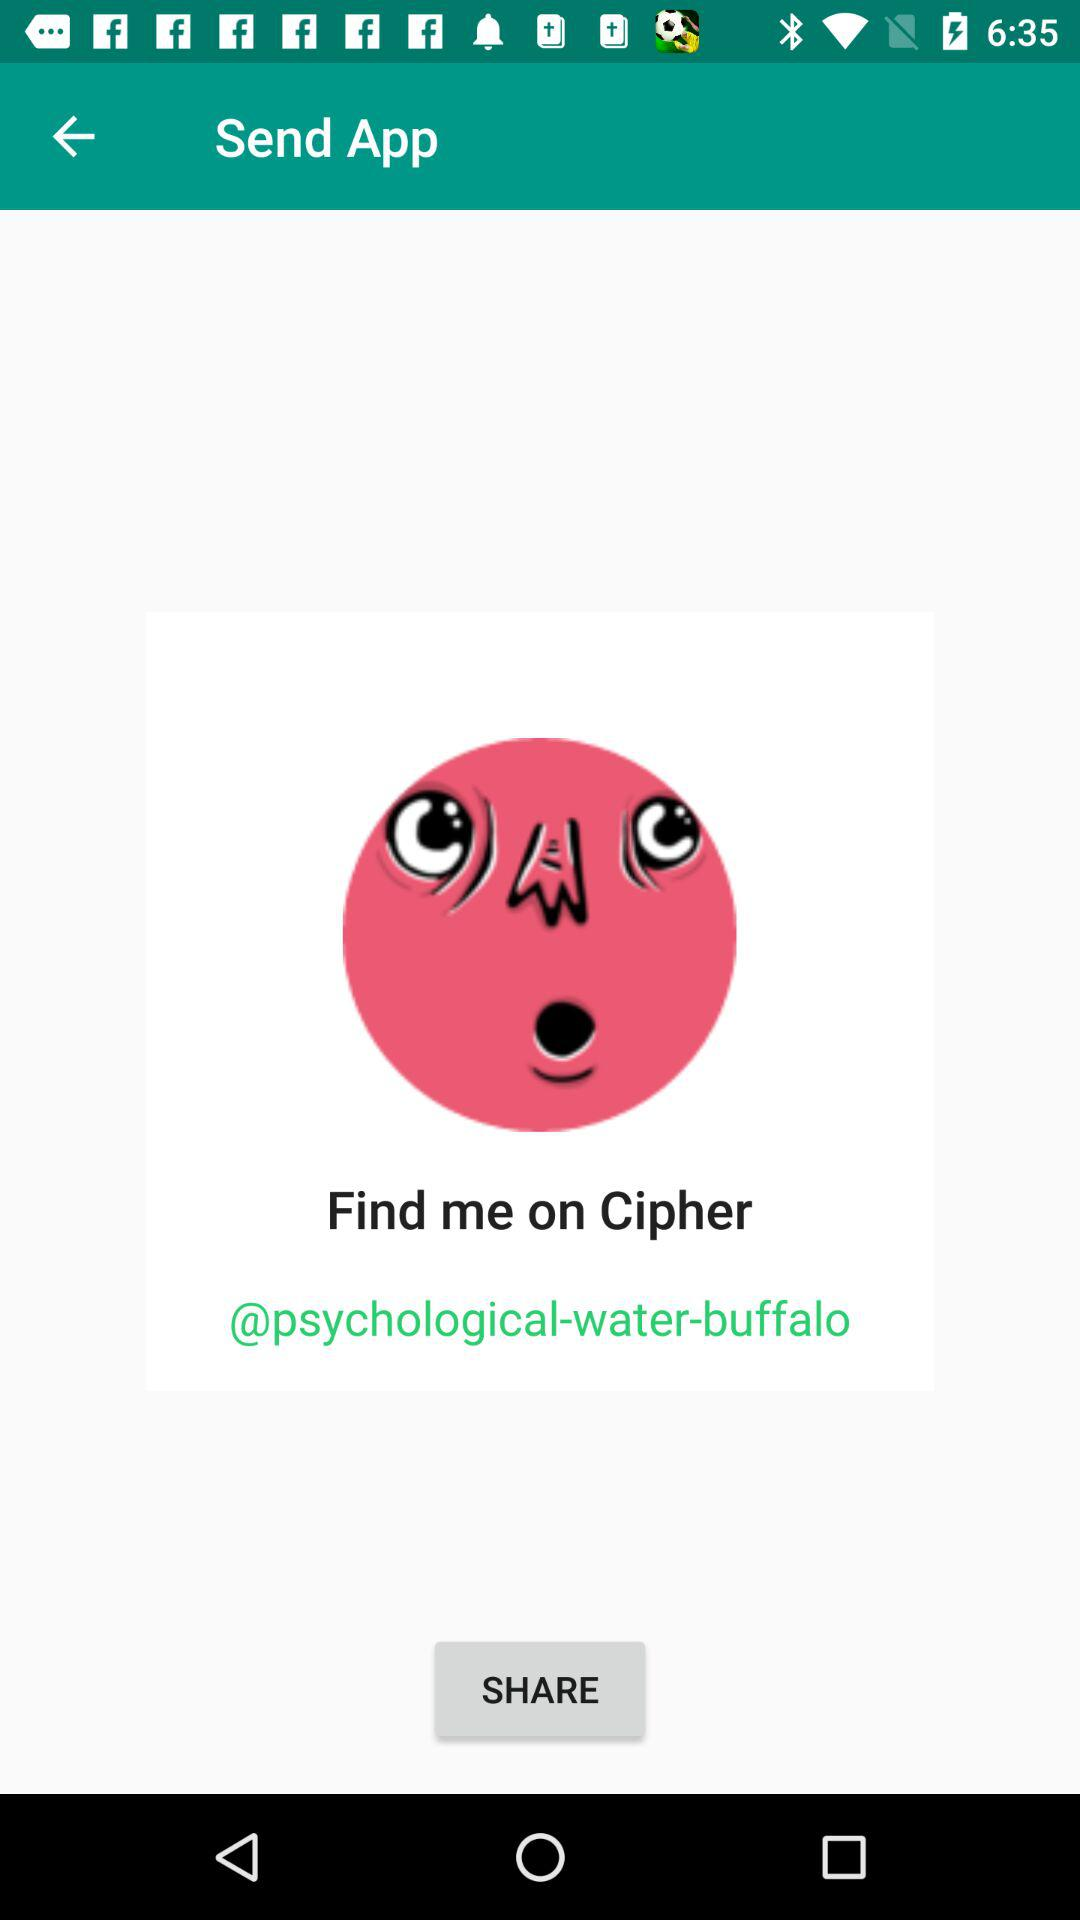What is the name of the application? The name of the application is "Cipher". 